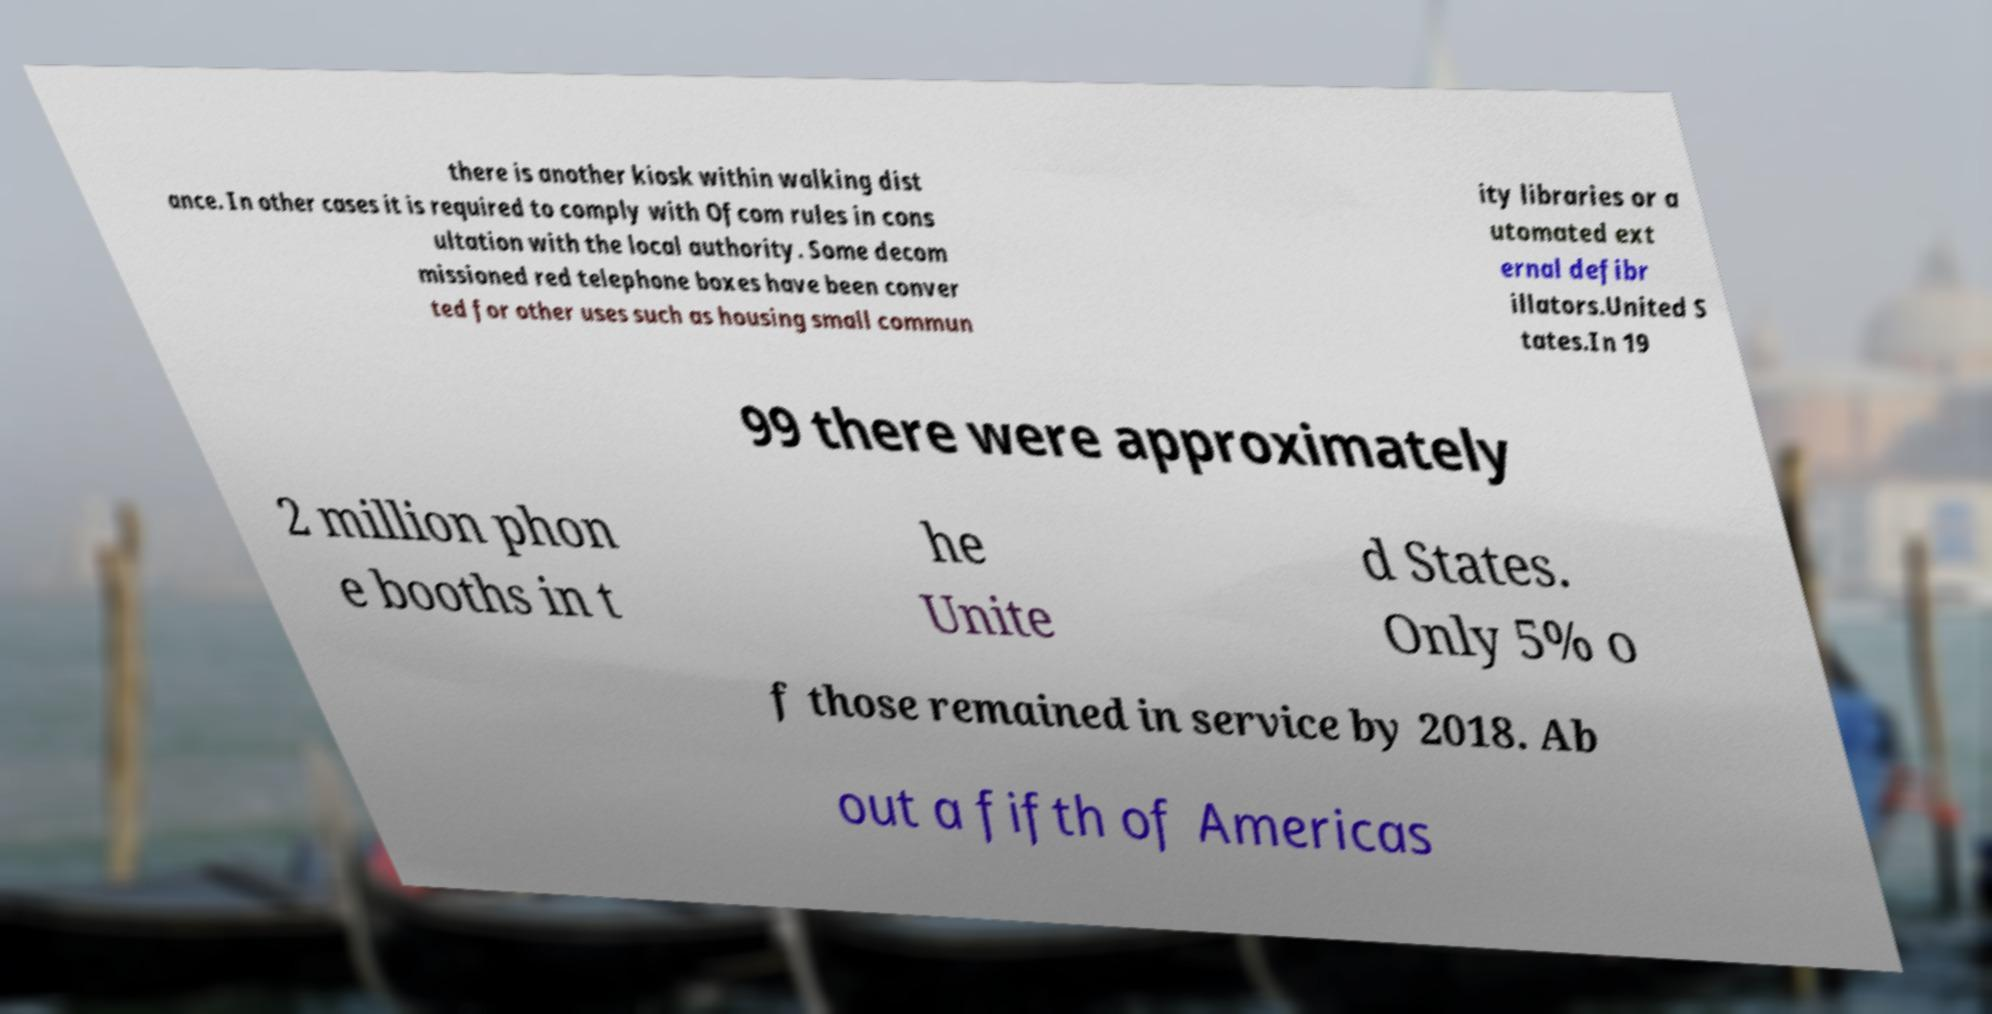For documentation purposes, I need the text within this image transcribed. Could you provide that? there is another kiosk within walking dist ance. In other cases it is required to comply with Ofcom rules in cons ultation with the local authority. Some decom missioned red telephone boxes have been conver ted for other uses such as housing small commun ity libraries or a utomated ext ernal defibr illators.United S tates.In 19 99 there were approximately 2 million phon e booths in t he Unite d States. Only 5% o f those remained in service by 2018. Ab out a fifth of Americas 